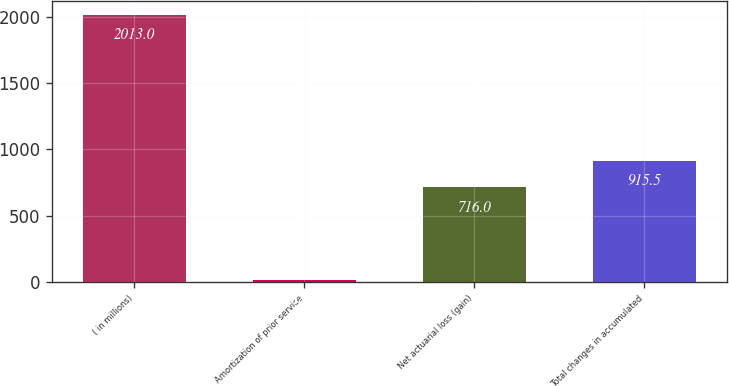<chart> <loc_0><loc_0><loc_500><loc_500><bar_chart><fcel>( in millions)<fcel>Amortization of prior service<fcel>Net actuarial loss (gain)<fcel>Total changes in accumulated<nl><fcel>2013<fcel>18<fcel>716<fcel>915.5<nl></chart> 